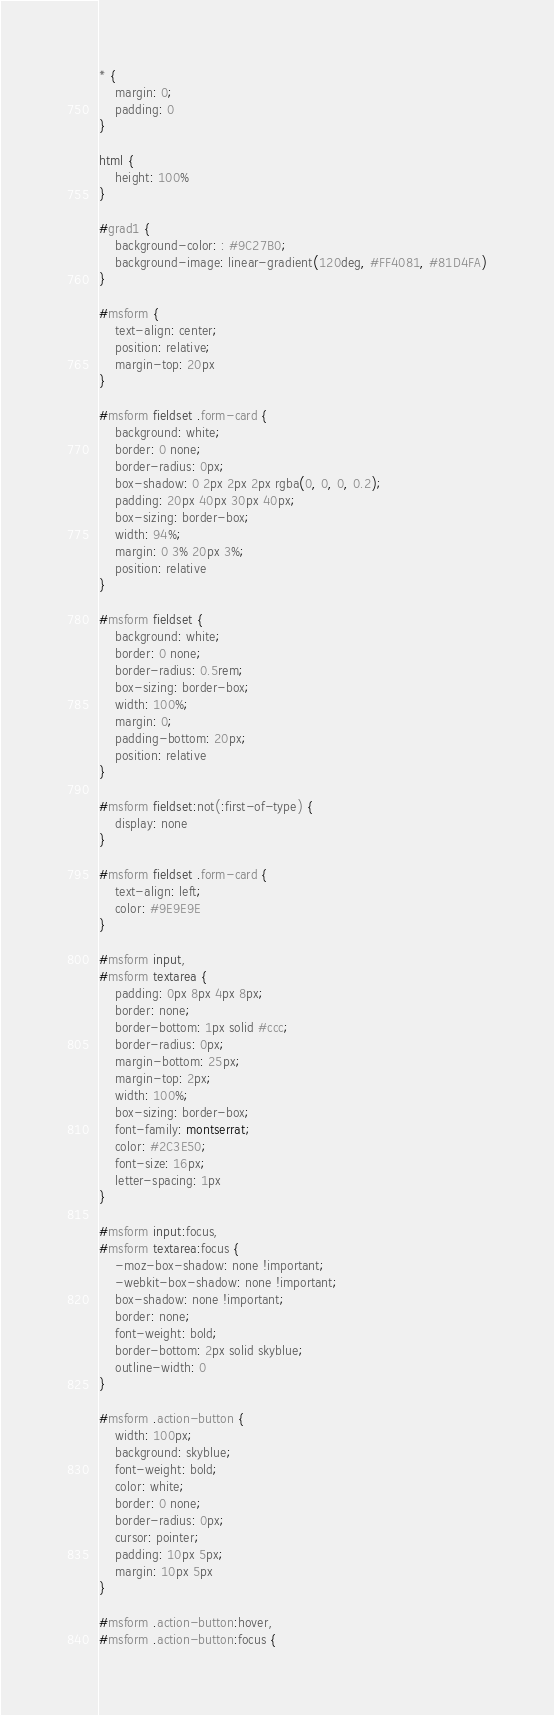Convert code to text. <code><loc_0><loc_0><loc_500><loc_500><_CSS_>* {
    margin: 0;
    padding: 0
}

html {
    height: 100%
}

#grad1 {
    background-color: : #9C27B0;
    background-image: linear-gradient(120deg, #FF4081, #81D4FA)
}

#msform {
    text-align: center;
    position: relative;
    margin-top: 20px
}

#msform fieldset .form-card {
    background: white;
    border: 0 none;
    border-radius: 0px;
    box-shadow: 0 2px 2px 2px rgba(0, 0, 0, 0.2);
    padding: 20px 40px 30px 40px;
    box-sizing: border-box;
    width: 94%;
    margin: 0 3% 20px 3%;
    position: relative
}

#msform fieldset {
    background: white;
    border: 0 none;
    border-radius: 0.5rem;
    box-sizing: border-box;
    width: 100%;
    margin: 0;
    padding-bottom: 20px;
    position: relative
}

#msform fieldset:not(:first-of-type) {
    display: none
}

#msform fieldset .form-card {
    text-align: left;
    color: #9E9E9E
}

#msform input,
#msform textarea {
    padding: 0px 8px 4px 8px;
    border: none;
    border-bottom: 1px solid #ccc;
    border-radius: 0px;
    margin-bottom: 25px;
    margin-top: 2px;
    width: 100%;
    box-sizing: border-box;
    font-family: montserrat;
    color: #2C3E50;
    font-size: 16px;
    letter-spacing: 1px
}

#msform input:focus,
#msform textarea:focus {
    -moz-box-shadow: none !important;
    -webkit-box-shadow: none !important;
    box-shadow: none !important;
    border: none;
    font-weight: bold;
    border-bottom: 2px solid skyblue;
    outline-width: 0
}

#msform .action-button {
    width: 100px;
    background: skyblue;
    font-weight: bold;
    color: white;
    border: 0 none;
    border-radius: 0px;
    cursor: pointer;
    padding: 10px 5px;
    margin: 10px 5px
}

#msform .action-button:hover,
#msform .action-button:focus {</code> 